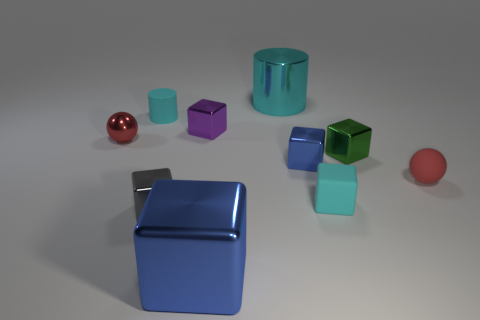How many objects are there in total in the image? There are nine objects in total displayed in the image. 